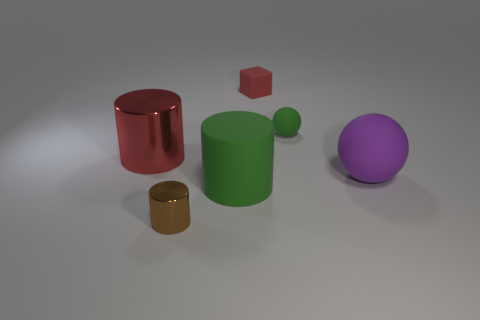Is the green cylinder made of the same material as the small red thing?
Offer a very short reply. Yes. What size is the thing that is on the left side of the green cylinder and in front of the large red cylinder?
Offer a very short reply. Small. What number of brown cylinders have the same size as the green rubber ball?
Make the answer very short. 1. What size is the red metal object that is to the left of the thing behind the tiny green thing?
Provide a short and direct response. Large. There is a green thing that is in front of the tiny green matte object; is it the same shape as the red thing left of the tiny shiny object?
Ensure brevity in your answer.  Yes. There is a big object that is right of the big red metal thing and left of the green rubber ball; what color is it?
Provide a succinct answer. Green. Are there any metallic balls that have the same color as the small cube?
Give a very brief answer. No. There is a object right of the green matte ball; what color is it?
Provide a succinct answer. Purple. There is a cylinder that is left of the brown object; is there a big matte sphere that is in front of it?
Your response must be concise. Yes. There is a big metallic thing; is it the same color as the object that is behind the green rubber sphere?
Keep it short and to the point. Yes. 